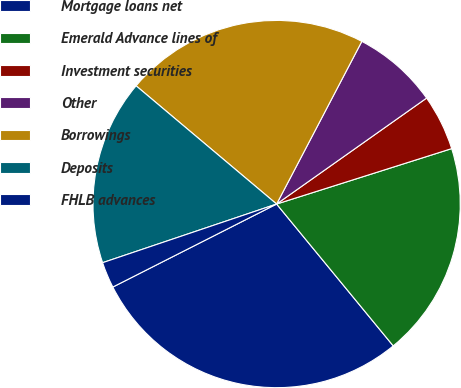<chart> <loc_0><loc_0><loc_500><loc_500><pie_chart><fcel>Mortgage loans net<fcel>Emerald Advance lines of<fcel>Investment securities<fcel>Other<fcel>Borrowings<fcel>Deposits<fcel>FHLB advances<nl><fcel>28.49%<fcel>18.93%<fcel>4.91%<fcel>7.53%<fcel>21.55%<fcel>16.31%<fcel>2.29%<nl></chart> 